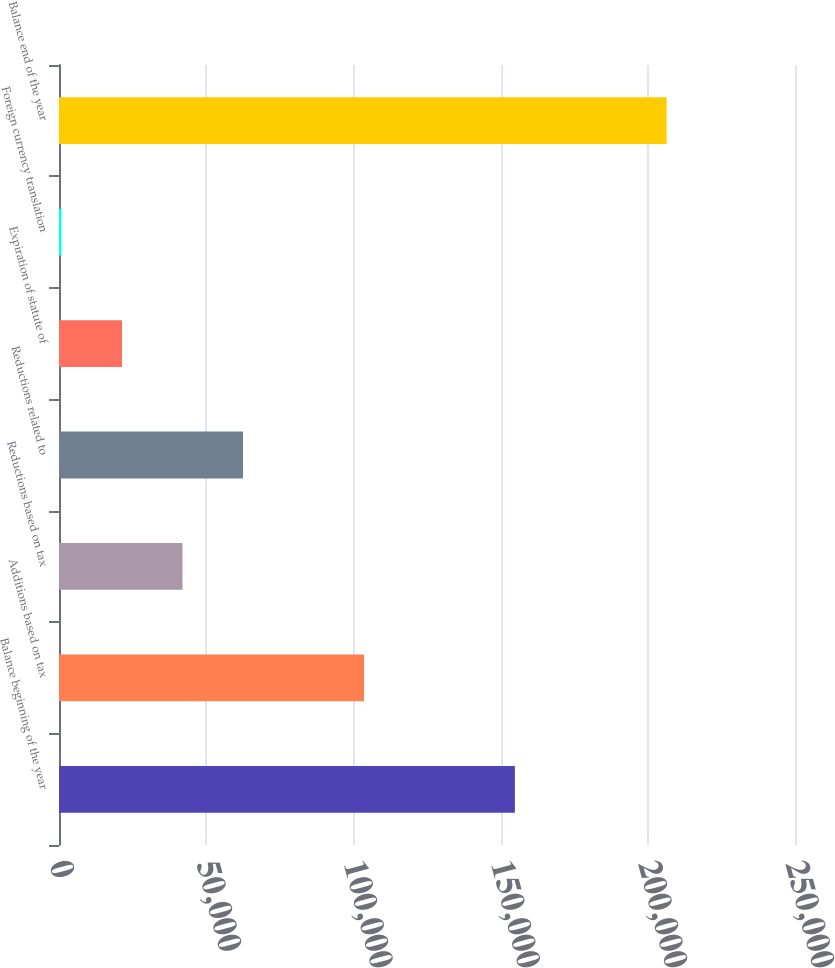Convert chart. <chart><loc_0><loc_0><loc_500><loc_500><bar_chart><fcel>Balance beginning of the year<fcel>Additions based on tax<fcel>Reductions based on tax<fcel>Reductions related to<fcel>Expiration of statute of<fcel>Foreign currency translation<fcel>Balance end of the year<nl><fcel>154848<fcel>103616<fcel>41949<fcel>62504.5<fcel>21393.5<fcel>838<fcel>206393<nl></chart> 